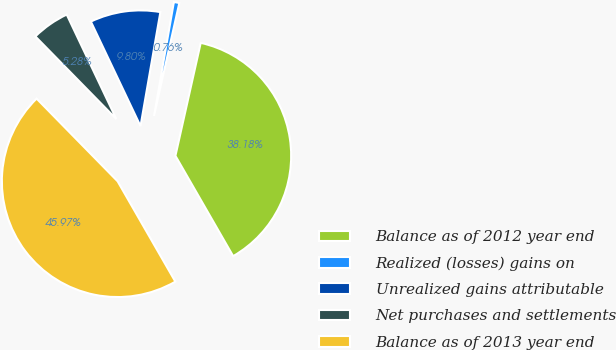<chart> <loc_0><loc_0><loc_500><loc_500><pie_chart><fcel>Balance as of 2012 year end<fcel>Realized (losses) gains on<fcel>Unrealized gains attributable<fcel>Net purchases and settlements<fcel>Balance as of 2013 year end<nl><fcel>38.18%<fcel>0.76%<fcel>9.8%<fcel>5.28%<fcel>45.97%<nl></chart> 